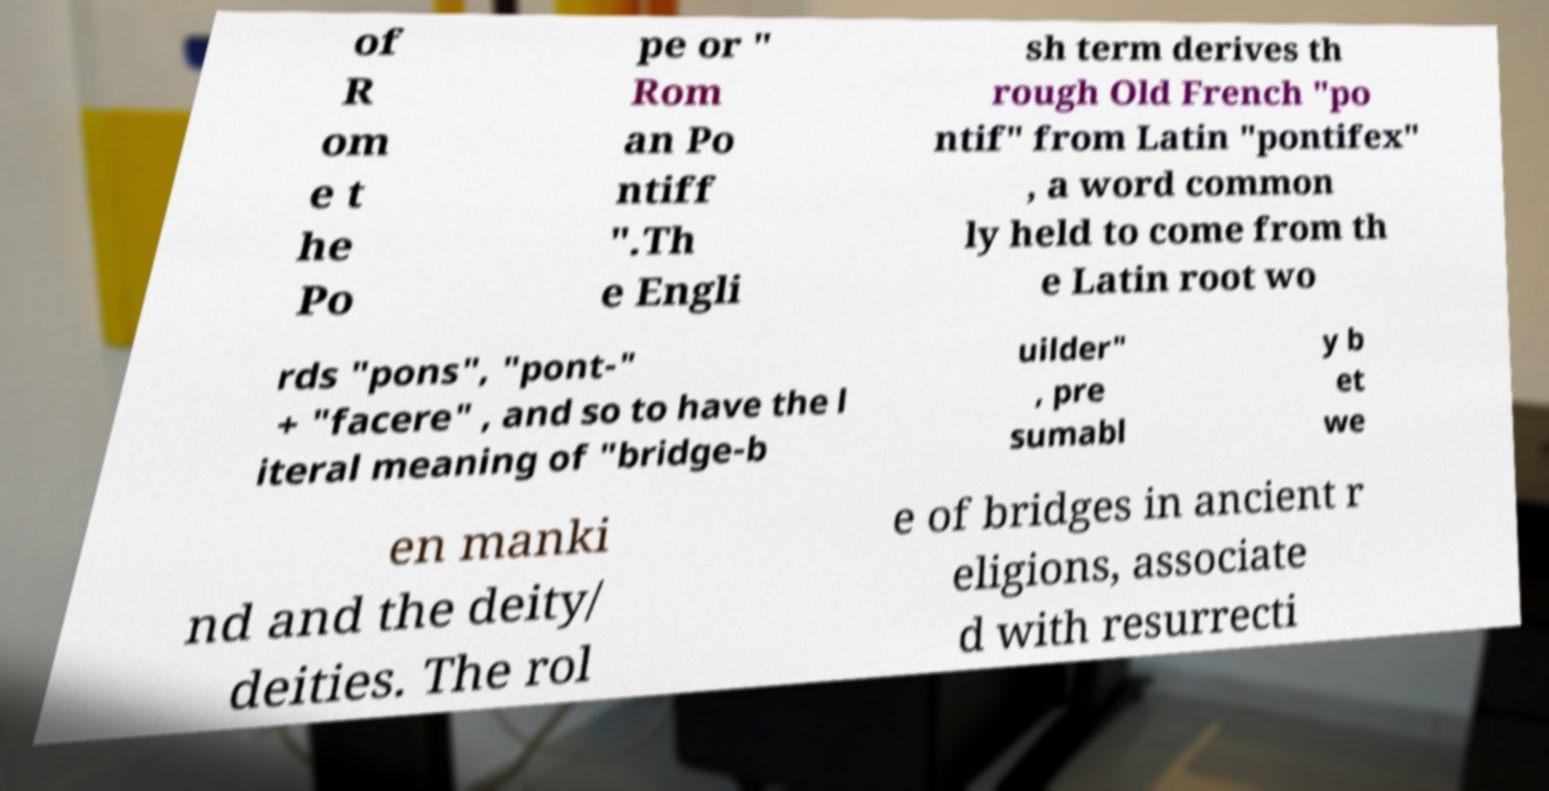Could you extract and type out the text from this image? of R om e t he Po pe or " Rom an Po ntiff ".Th e Engli sh term derives th rough Old French "po ntif" from Latin "pontifex" , a word common ly held to come from th e Latin root wo rds "pons", "pont-" + "facere" , and so to have the l iteral meaning of "bridge-b uilder" , pre sumabl y b et we en manki nd and the deity/ deities. The rol e of bridges in ancient r eligions, associate d with resurrecti 